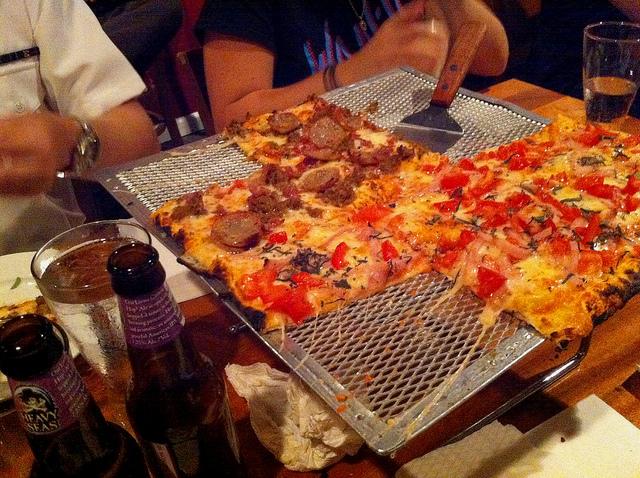Is this homemade pizza?
Be succinct. No. Is the crust on the pizza burnt?
Concise answer only. No. What is in the glass?
Answer briefly. Beer. 